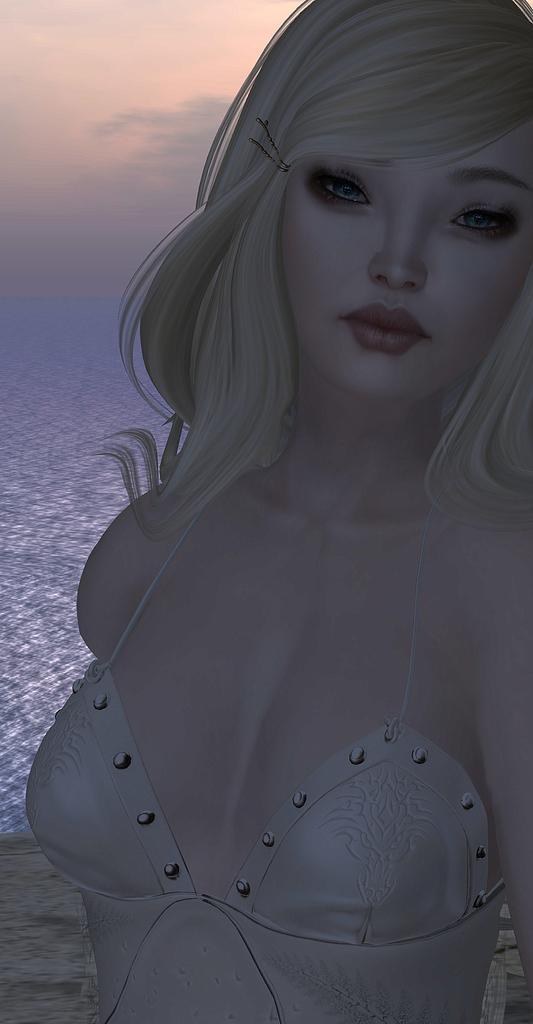Could you give a brief overview of what you see in this image? This is an animated image. There is a woman in the front. There is water at the back and sky at the top. 